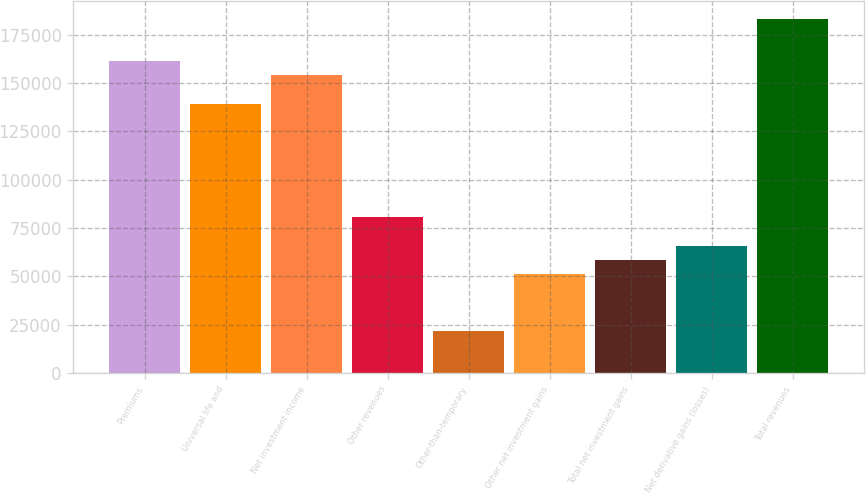Convert chart. <chart><loc_0><loc_0><loc_500><loc_500><bar_chart><fcel>Premiums<fcel>Universal life and<fcel>Net investment income<fcel>Other revenues<fcel>Other-than-temporary<fcel>Other net investment gains<fcel>Total net investment gains<fcel>Net derivative gains (losses)<fcel>Total revenues<nl><fcel>161294<fcel>139299<fcel>153962<fcel>80647.5<fcel>21995.7<fcel>51321.6<fcel>58653.1<fcel>65984.6<fcel>183288<nl></chart> 